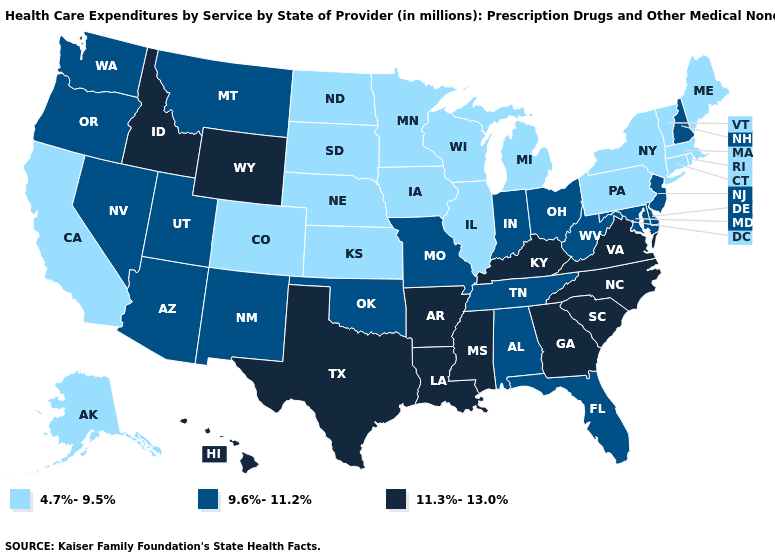What is the highest value in states that border North Dakota?
Give a very brief answer. 9.6%-11.2%. Is the legend a continuous bar?
Give a very brief answer. No. Among the states that border Missouri , which have the highest value?
Keep it brief. Arkansas, Kentucky. Among the states that border Illinois , which have the highest value?
Write a very short answer. Kentucky. Which states have the lowest value in the South?
Keep it brief. Alabama, Delaware, Florida, Maryland, Oklahoma, Tennessee, West Virginia. What is the value of Wyoming?
Write a very short answer. 11.3%-13.0%. Among the states that border Wyoming , does Idaho have the lowest value?
Answer briefly. No. What is the value of North Carolina?
Concise answer only. 11.3%-13.0%. What is the value of Illinois?
Write a very short answer. 4.7%-9.5%. Does Missouri have the lowest value in the USA?
Answer briefly. No. Is the legend a continuous bar?
Quick response, please. No. Does the first symbol in the legend represent the smallest category?
Keep it brief. Yes. Does Wyoming have the highest value in the USA?
Be succinct. Yes. Among the states that border New York , does New Jersey have the lowest value?
Concise answer only. No. 